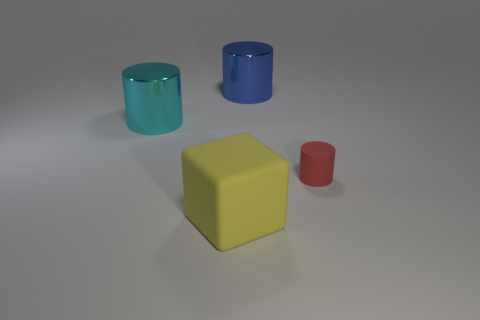Add 1 big metallic cubes. How many objects exist? 5 Subtract all cubes. How many objects are left? 3 Add 2 small red matte cylinders. How many small red matte cylinders are left? 3 Add 4 blue cylinders. How many blue cylinders exist? 5 Subtract 0 red blocks. How many objects are left? 4 Subtract all red objects. Subtract all tiny red things. How many objects are left? 2 